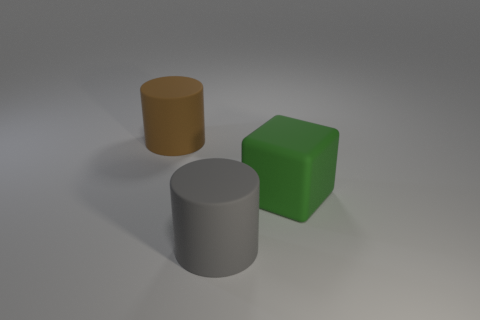How many rubber things are either big green spheres or gray objects?
Provide a succinct answer. 1. What material is the big brown object?
Offer a very short reply. Rubber. What material is the object that is left of the large cylinder right of the large cylinder that is left of the gray cylinder?
Provide a succinct answer. Rubber. There is a green rubber thing that is the same size as the brown matte thing; what is its shape?
Offer a very short reply. Cube. How many things are either large gray rubber cylinders or matte cylinders that are on the right side of the brown object?
Your response must be concise. 1. Does the object behind the block have the same material as the cylinder that is in front of the big brown matte cylinder?
Give a very brief answer. Yes. How many brown objects are either big cubes or cylinders?
Offer a very short reply. 1. How big is the gray cylinder?
Provide a succinct answer. Large. Is the number of big matte objects that are in front of the big brown matte thing greater than the number of large brown rubber objects?
Provide a short and direct response. Yes. How many large gray cylinders are to the left of the large green matte cube?
Provide a short and direct response. 1. 